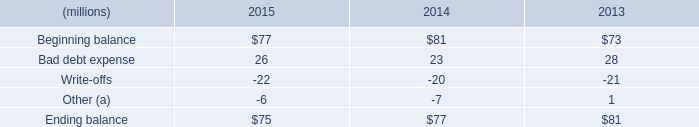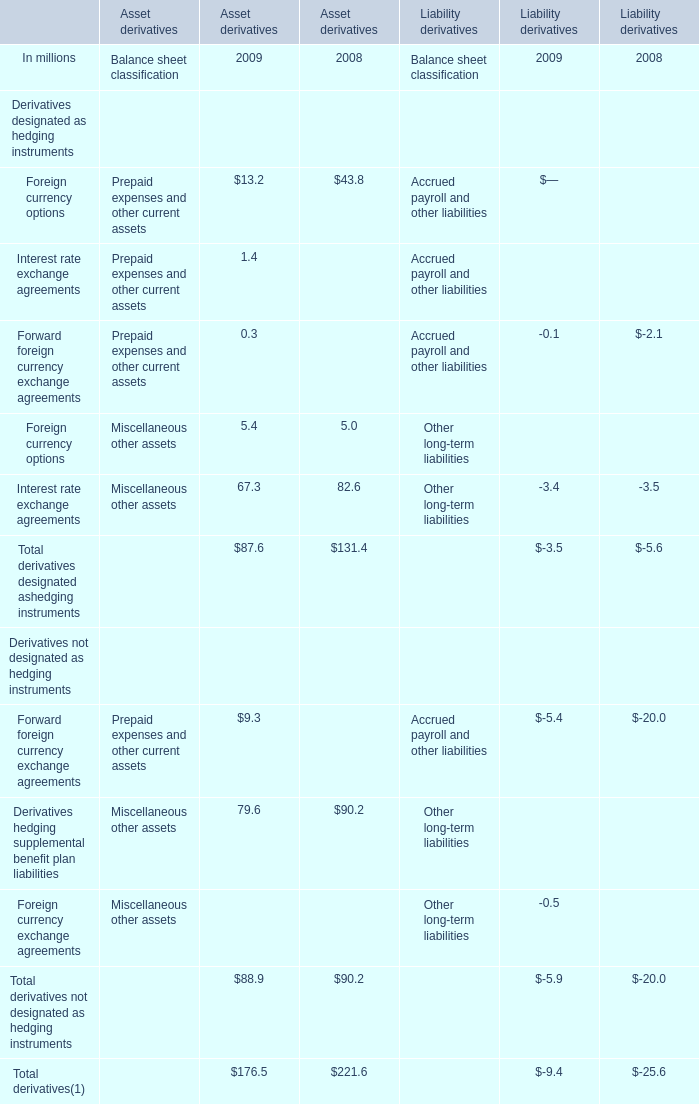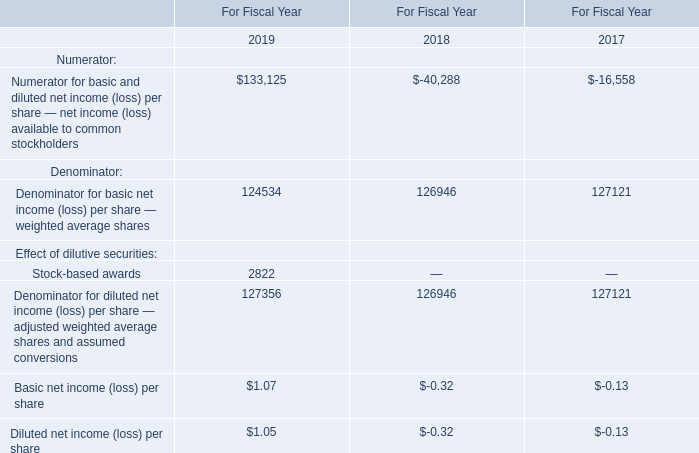What do all elements for Asset derivatives sum up in 2009 excluding Foreign currency options and Interest rate exchange agreements? (in million) 
Computations: ((((0.3 + 5.4) + 67.3) + 9.3) + 79.6)
Answer: 161.9. 